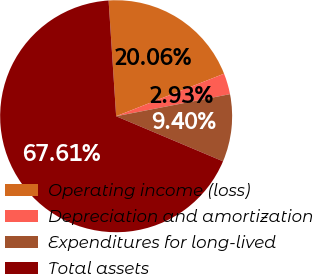Convert chart. <chart><loc_0><loc_0><loc_500><loc_500><pie_chart><fcel>Operating income (loss)<fcel>Depreciation and amortization<fcel>Expenditures for long-lived<fcel>Total assets<nl><fcel>20.06%<fcel>2.93%<fcel>9.4%<fcel>67.61%<nl></chart> 